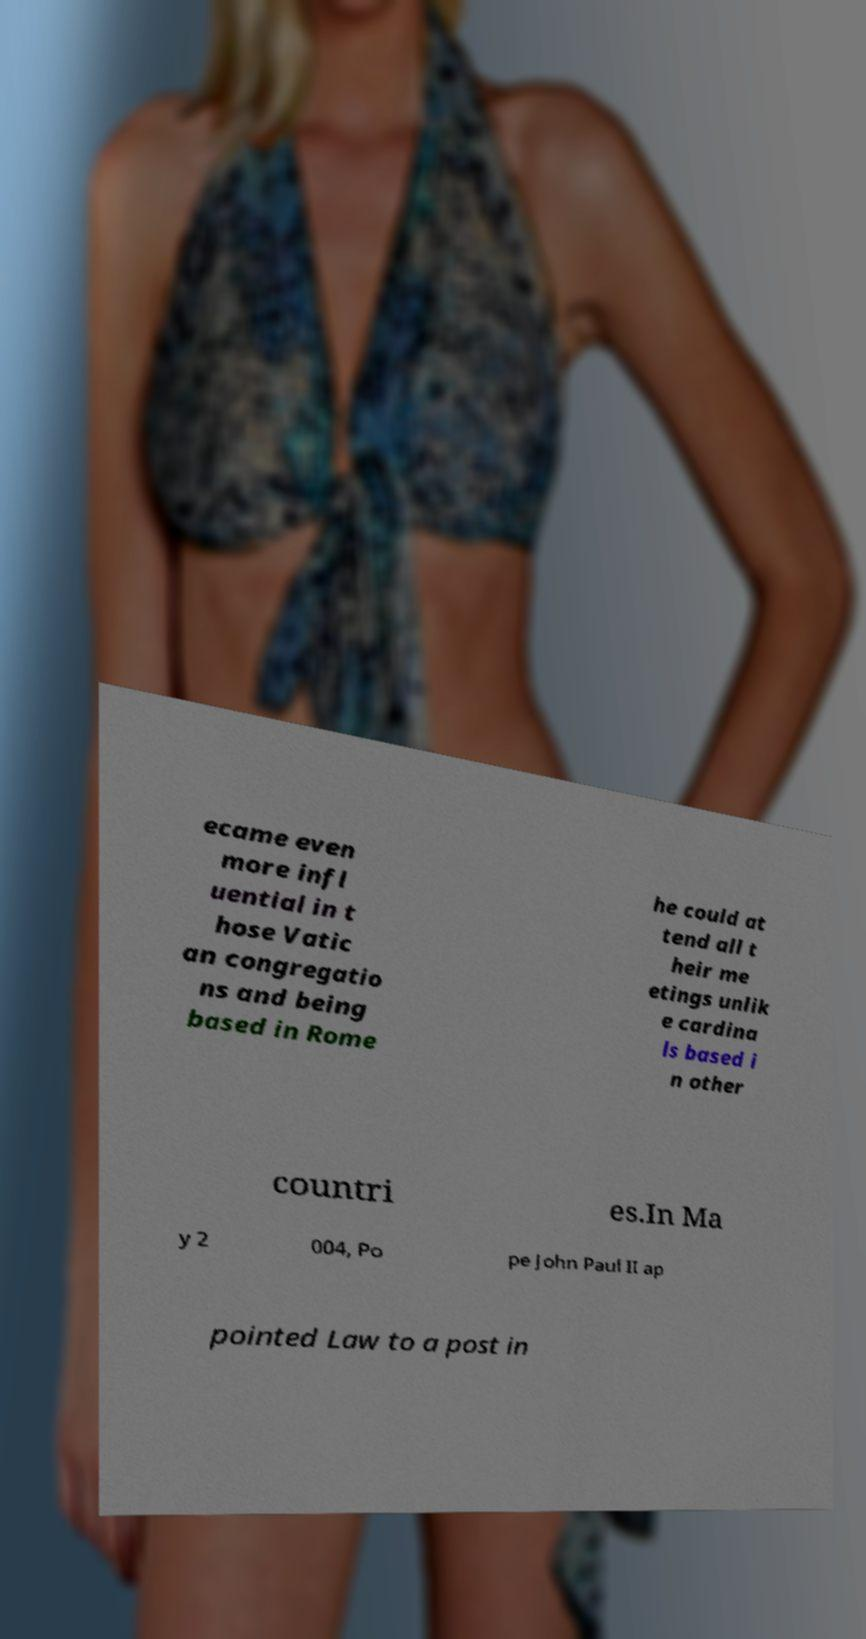Can you accurately transcribe the text from the provided image for me? ecame even more infl uential in t hose Vatic an congregatio ns and being based in Rome he could at tend all t heir me etings unlik e cardina ls based i n other countri es.In Ma y 2 004, Po pe John Paul II ap pointed Law to a post in 